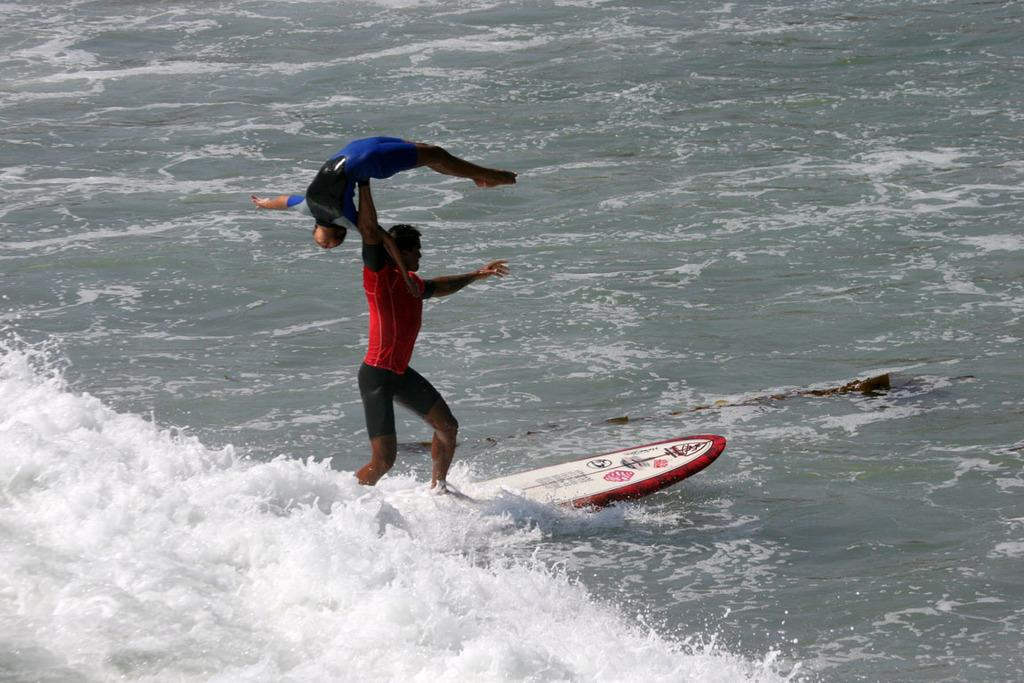What is the main element in the image? There is water in the image. What is on the water in the image? There is a surfing board on the water. Who or what is on the surfing board? There is a person standing on the surfing board. What is the person on the surfing board doing? The person on the surfing board is holding another person. What type of grass is growing on the surfing board in the image? There is no grass present on the surfing board in the image. 